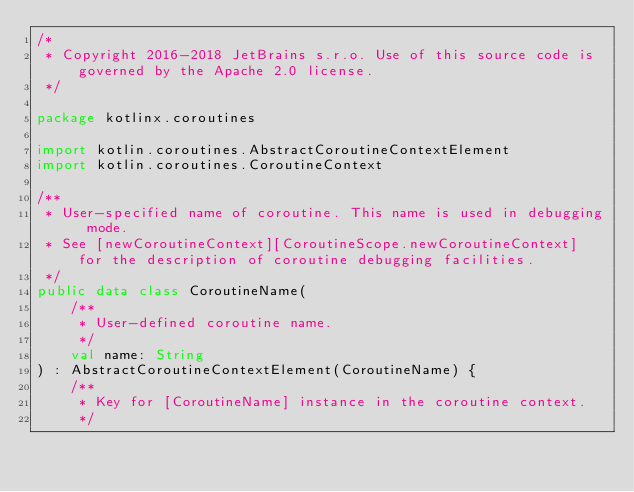Convert code to text. <code><loc_0><loc_0><loc_500><loc_500><_Kotlin_>/*
 * Copyright 2016-2018 JetBrains s.r.o. Use of this source code is governed by the Apache 2.0 license.
 */

package kotlinx.coroutines

import kotlin.coroutines.AbstractCoroutineContextElement
import kotlin.coroutines.CoroutineContext

/**
 * User-specified name of coroutine. This name is used in debugging mode.
 * See [newCoroutineContext][CoroutineScope.newCoroutineContext] for the description of coroutine debugging facilities.
 */
public data class CoroutineName(
    /**
     * User-defined coroutine name.
     */
    val name: String
) : AbstractCoroutineContextElement(CoroutineName) {
    /**
     * Key for [CoroutineName] instance in the coroutine context.
     */</code> 